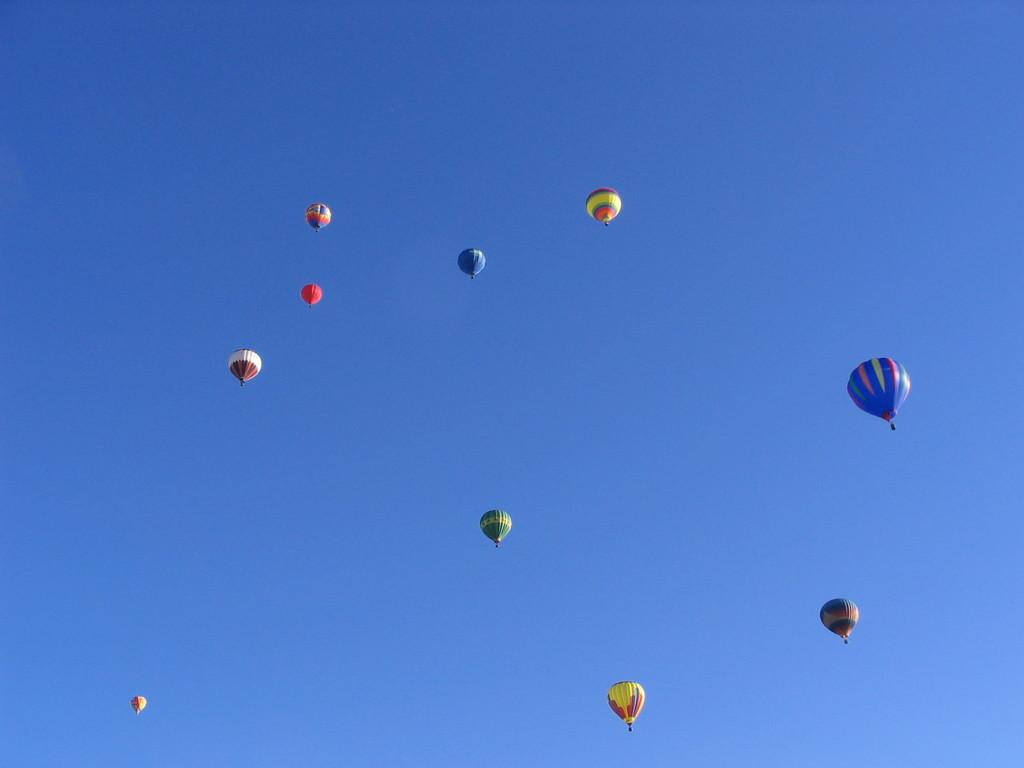What is the main subject of the image? The main subject of the image is hot air balloons. What are the hot air balloons doing in the image? The hot air balloons are flying in the air. What can be seen in the background of the image? The sky is visible in the background of the image. What is the color of the sky in the image? The color of the sky is blue. How many geese are visible in the image? There are no geese present in the image; it features hot air balloons flying in the sky. 